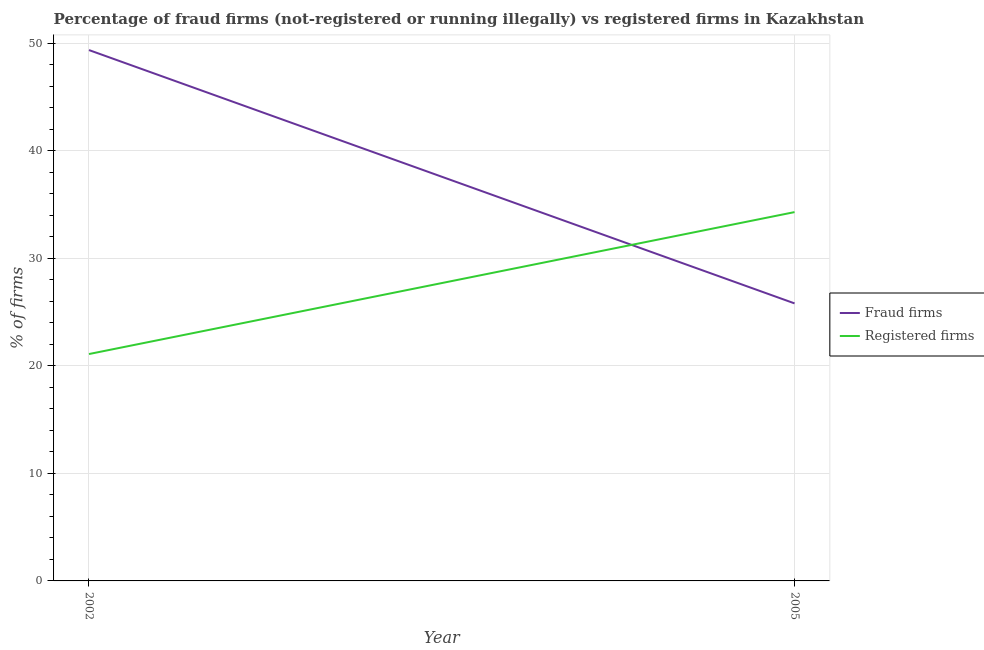Does the line corresponding to percentage of registered firms intersect with the line corresponding to percentage of fraud firms?
Keep it short and to the point. Yes. Is the number of lines equal to the number of legend labels?
Your answer should be very brief. Yes. What is the percentage of fraud firms in 2005?
Make the answer very short. 25.81. Across all years, what is the maximum percentage of fraud firms?
Your response must be concise. 49.37. Across all years, what is the minimum percentage of registered firms?
Provide a succinct answer. 21.1. In which year was the percentage of fraud firms maximum?
Provide a succinct answer. 2002. What is the total percentage of fraud firms in the graph?
Offer a terse response. 75.18. What is the difference between the percentage of registered firms in 2002 and that in 2005?
Offer a terse response. -13.2. What is the difference between the percentage of fraud firms in 2005 and the percentage of registered firms in 2002?
Your answer should be very brief. 4.71. What is the average percentage of fraud firms per year?
Your answer should be compact. 37.59. In the year 2005, what is the difference between the percentage of fraud firms and percentage of registered firms?
Offer a very short reply. -8.49. What is the ratio of the percentage of registered firms in 2002 to that in 2005?
Make the answer very short. 0.62. Is the percentage of registered firms strictly greater than the percentage of fraud firms over the years?
Your response must be concise. No. How many years are there in the graph?
Provide a succinct answer. 2. What is the difference between two consecutive major ticks on the Y-axis?
Your answer should be compact. 10. Are the values on the major ticks of Y-axis written in scientific E-notation?
Give a very brief answer. No. Does the graph contain any zero values?
Your response must be concise. No. Where does the legend appear in the graph?
Make the answer very short. Center right. How many legend labels are there?
Keep it short and to the point. 2. What is the title of the graph?
Your answer should be very brief. Percentage of fraud firms (not-registered or running illegally) vs registered firms in Kazakhstan. What is the label or title of the Y-axis?
Your response must be concise. % of firms. What is the % of firms in Fraud firms in 2002?
Keep it short and to the point. 49.37. What is the % of firms of Registered firms in 2002?
Provide a succinct answer. 21.1. What is the % of firms of Fraud firms in 2005?
Provide a short and direct response. 25.81. What is the % of firms of Registered firms in 2005?
Ensure brevity in your answer.  34.3. Across all years, what is the maximum % of firms in Fraud firms?
Give a very brief answer. 49.37. Across all years, what is the maximum % of firms in Registered firms?
Ensure brevity in your answer.  34.3. Across all years, what is the minimum % of firms of Fraud firms?
Ensure brevity in your answer.  25.81. Across all years, what is the minimum % of firms of Registered firms?
Provide a succinct answer. 21.1. What is the total % of firms of Fraud firms in the graph?
Offer a very short reply. 75.18. What is the total % of firms of Registered firms in the graph?
Offer a very short reply. 55.4. What is the difference between the % of firms in Fraud firms in 2002 and that in 2005?
Provide a succinct answer. 23.56. What is the difference between the % of firms of Registered firms in 2002 and that in 2005?
Your response must be concise. -13.2. What is the difference between the % of firms of Fraud firms in 2002 and the % of firms of Registered firms in 2005?
Give a very brief answer. 15.07. What is the average % of firms in Fraud firms per year?
Your answer should be compact. 37.59. What is the average % of firms of Registered firms per year?
Provide a short and direct response. 27.7. In the year 2002, what is the difference between the % of firms in Fraud firms and % of firms in Registered firms?
Provide a succinct answer. 28.27. In the year 2005, what is the difference between the % of firms in Fraud firms and % of firms in Registered firms?
Make the answer very short. -8.49. What is the ratio of the % of firms in Fraud firms in 2002 to that in 2005?
Ensure brevity in your answer.  1.91. What is the ratio of the % of firms of Registered firms in 2002 to that in 2005?
Provide a short and direct response. 0.62. What is the difference between the highest and the second highest % of firms of Fraud firms?
Offer a terse response. 23.56. What is the difference between the highest and the lowest % of firms of Fraud firms?
Provide a short and direct response. 23.56. What is the difference between the highest and the lowest % of firms of Registered firms?
Your answer should be compact. 13.2. 